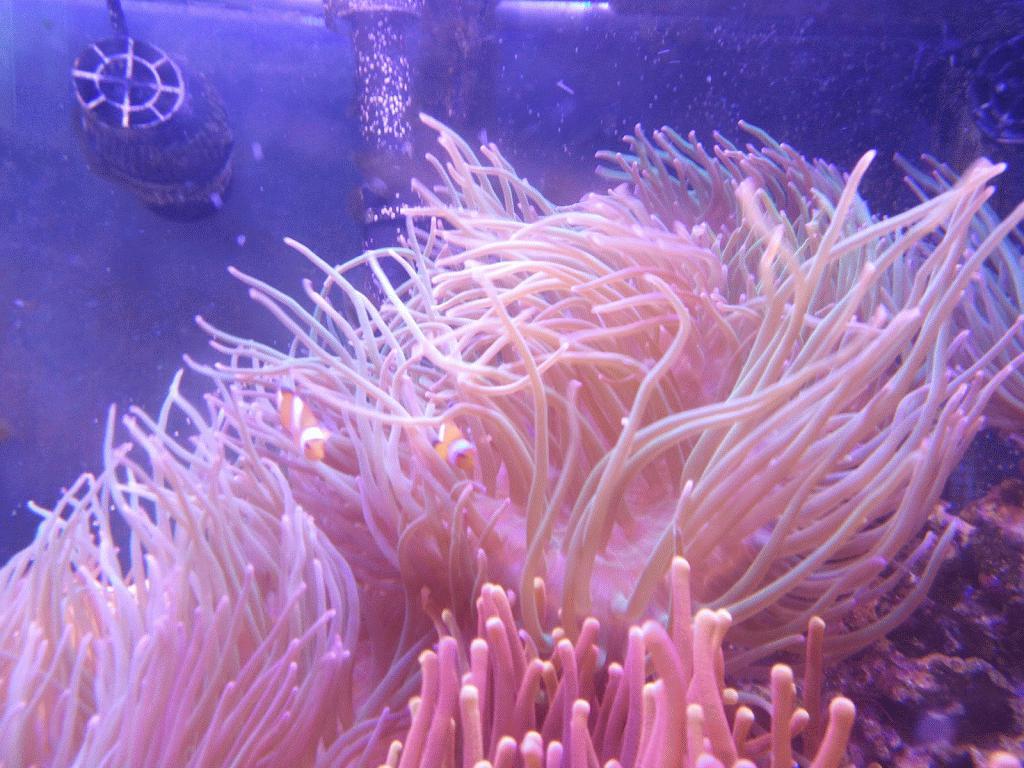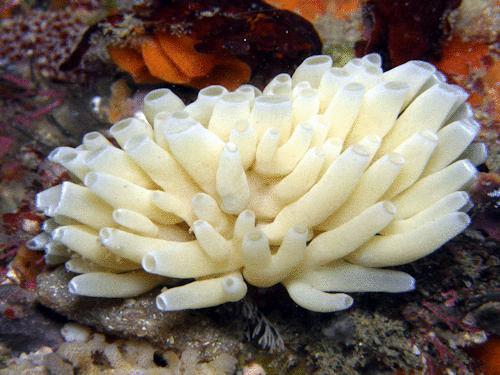The first image is the image on the left, the second image is the image on the right. Assess this claim about the two images: "The left image contains only pink anemone, and the right image includes an anemone with tendrils sprouting upward.". Correct or not? Answer yes or no. Yes. The first image is the image on the left, the second image is the image on the right. Analyze the images presented: Is the assertion "The anemones in the left image is pink." valid? Answer yes or no. Yes. 